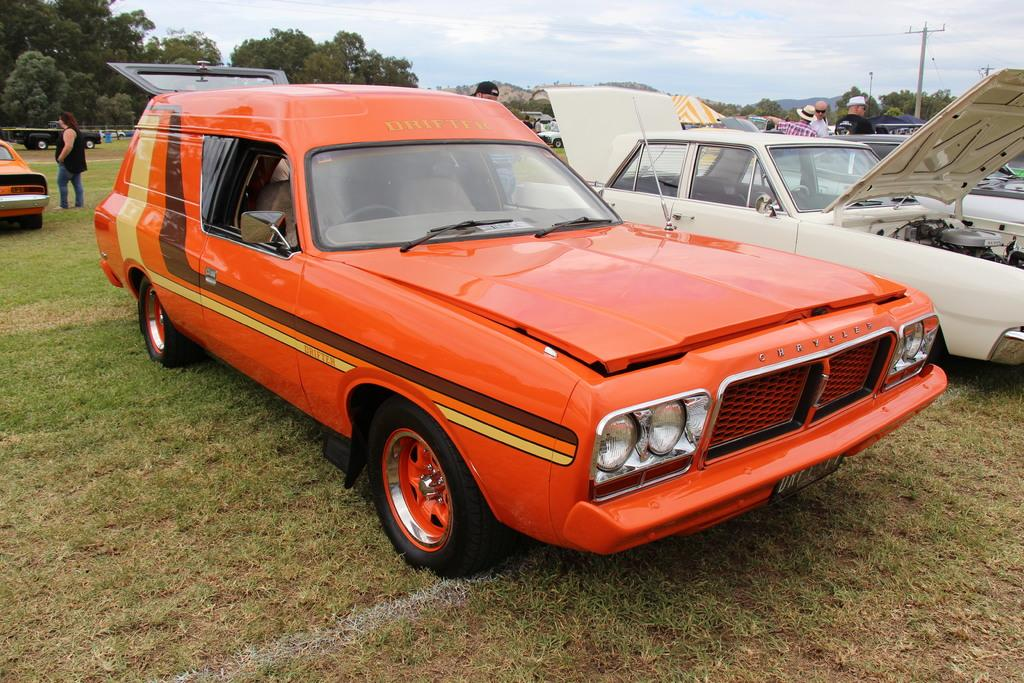What type of vehicles can be seen in the image? There are cars in the image. What are the people in the image doing? The people in the image are standing on the ground. What object can be seen in the image that is tall and vertical? There is a pole in the image. image. What type of natural vegetation is present in the image? There are trees in the image. What type of landscape feature can be seen in the background of the image? There are mountains in the background of the image. What is visible in the sky in the image? The sky is visible in the background of the image, and clouds are present. What type of vegetable is being used as a curtain in the image? There is no vegetable being used as a curtain in the image; the image does not depict any curtains. How many copies of the same car can be seen in the image? There is no indication of multiple copies of the same car in the image; only one car is visible. 